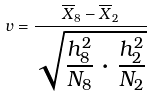<formula> <loc_0><loc_0><loc_500><loc_500>v = \frac { \overline { X } _ { 8 } - \overline { X } _ { 2 } } { \sqrt { \frac { h _ { 8 } ^ { 2 } } { N _ { 8 } } \cdot \frac { h _ { 2 } ^ { 2 } } { N _ { 2 } } } }</formula> 